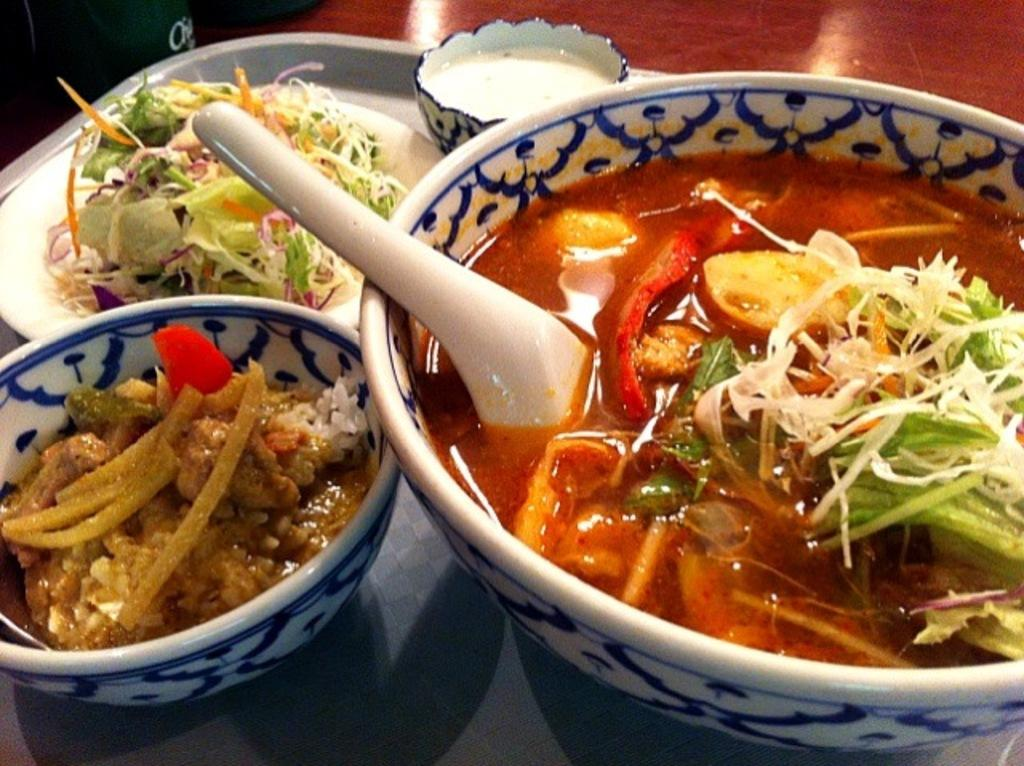What is the main object in the image? There is a tree in the image. What can be seen above the tree? Above the tree, there are plates, bowls, spoons, and food visible. What is the color of the top part of the image? The top of the image has a brown color. Can you see the grandmother cooking in the image? There is no grandmother or any indication of cooking present in the image. 